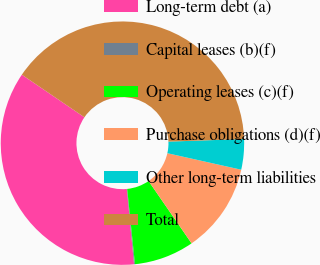Convert chart. <chart><loc_0><loc_0><loc_500><loc_500><pie_chart><fcel>Long-term debt (a)<fcel>Capital leases (b)(f)<fcel>Operating leases (c)(f)<fcel>Purchase obligations (d)(f)<fcel>Other long-term liabilities<fcel>Total<nl><fcel>36.03%<fcel>0.12%<fcel>7.97%<fcel>11.89%<fcel>4.04%<fcel>39.95%<nl></chart> 